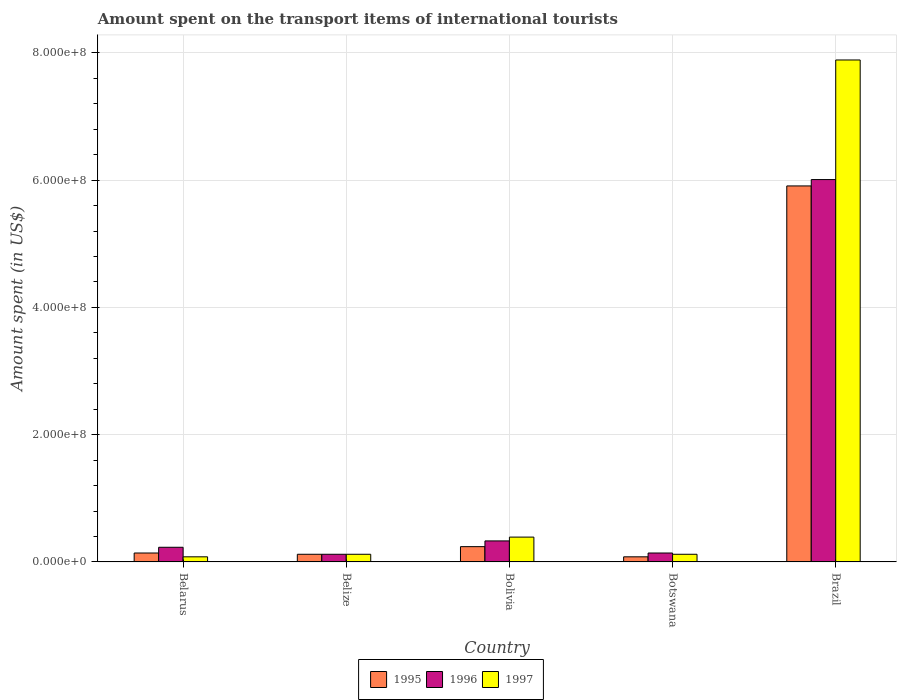How many groups of bars are there?
Your answer should be compact. 5. Are the number of bars per tick equal to the number of legend labels?
Give a very brief answer. Yes. How many bars are there on the 5th tick from the left?
Make the answer very short. 3. How many bars are there on the 1st tick from the right?
Ensure brevity in your answer.  3. What is the label of the 1st group of bars from the left?
Keep it short and to the point. Belarus. In how many cases, is the number of bars for a given country not equal to the number of legend labels?
Make the answer very short. 0. Across all countries, what is the maximum amount spent on the transport items of international tourists in 1995?
Provide a short and direct response. 5.91e+08. Across all countries, what is the minimum amount spent on the transport items of international tourists in 1997?
Provide a succinct answer. 8.00e+06. In which country was the amount spent on the transport items of international tourists in 1995 maximum?
Offer a terse response. Brazil. In which country was the amount spent on the transport items of international tourists in 1997 minimum?
Keep it short and to the point. Belarus. What is the total amount spent on the transport items of international tourists in 1997 in the graph?
Provide a short and direct response. 8.60e+08. What is the difference between the amount spent on the transport items of international tourists in 1997 in Belarus and that in Botswana?
Provide a succinct answer. -4.00e+06. What is the difference between the amount spent on the transport items of international tourists in 1996 in Bolivia and the amount spent on the transport items of international tourists in 1997 in Belarus?
Your answer should be very brief. 2.50e+07. What is the average amount spent on the transport items of international tourists in 1997 per country?
Make the answer very short. 1.72e+08. What is the ratio of the amount spent on the transport items of international tourists in 1997 in Belarus to that in Botswana?
Keep it short and to the point. 0.67. Is the amount spent on the transport items of international tourists in 1996 in Belarus less than that in Brazil?
Your answer should be very brief. Yes. Is the difference between the amount spent on the transport items of international tourists in 1996 in Bolivia and Brazil greater than the difference between the amount spent on the transport items of international tourists in 1995 in Bolivia and Brazil?
Give a very brief answer. No. What is the difference between the highest and the second highest amount spent on the transport items of international tourists in 1995?
Your answer should be compact. 5.67e+08. What is the difference between the highest and the lowest amount spent on the transport items of international tourists in 1995?
Keep it short and to the point. 5.83e+08. What does the 2nd bar from the left in Bolivia represents?
Offer a terse response. 1996. What does the 3rd bar from the right in Bolivia represents?
Offer a terse response. 1995. Is it the case that in every country, the sum of the amount spent on the transport items of international tourists in 1995 and amount spent on the transport items of international tourists in 1996 is greater than the amount spent on the transport items of international tourists in 1997?
Your answer should be compact. Yes. Are all the bars in the graph horizontal?
Your response must be concise. No. Does the graph contain any zero values?
Ensure brevity in your answer.  No. How many legend labels are there?
Make the answer very short. 3. What is the title of the graph?
Your answer should be compact. Amount spent on the transport items of international tourists. Does "1965" appear as one of the legend labels in the graph?
Your answer should be very brief. No. What is the label or title of the X-axis?
Provide a short and direct response. Country. What is the label or title of the Y-axis?
Provide a succinct answer. Amount spent (in US$). What is the Amount spent (in US$) of 1995 in Belarus?
Provide a short and direct response. 1.40e+07. What is the Amount spent (in US$) in 1996 in Belarus?
Give a very brief answer. 2.30e+07. What is the Amount spent (in US$) in 1997 in Belarus?
Give a very brief answer. 8.00e+06. What is the Amount spent (in US$) of 1996 in Belize?
Ensure brevity in your answer.  1.20e+07. What is the Amount spent (in US$) of 1995 in Bolivia?
Your answer should be very brief. 2.40e+07. What is the Amount spent (in US$) in 1996 in Bolivia?
Offer a terse response. 3.30e+07. What is the Amount spent (in US$) in 1997 in Bolivia?
Give a very brief answer. 3.90e+07. What is the Amount spent (in US$) in 1996 in Botswana?
Offer a very short reply. 1.40e+07. What is the Amount spent (in US$) in 1997 in Botswana?
Make the answer very short. 1.20e+07. What is the Amount spent (in US$) in 1995 in Brazil?
Provide a short and direct response. 5.91e+08. What is the Amount spent (in US$) of 1996 in Brazil?
Your answer should be compact. 6.01e+08. What is the Amount spent (in US$) of 1997 in Brazil?
Your answer should be compact. 7.89e+08. Across all countries, what is the maximum Amount spent (in US$) of 1995?
Offer a very short reply. 5.91e+08. Across all countries, what is the maximum Amount spent (in US$) of 1996?
Your answer should be compact. 6.01e+08. Across all countries, what is the maximum Amount spent (in US$) in 1997?
Keep it short and to the point. 7.89e+08. Across all countries, what is the minimum Amount spent (in US$) in 1996?
Offer a very short reply. 1.20e+07. What is the total Amount spent (in US$) of 1995 in the graph?
Provide a short and direct response. 6.49e+08. What is the total Amount spent (in US$) of 1996 in the graph?
Give a very brief answer. 6.83e+08. What is the total Amount spent (in US$) of 1997 in the graph?
Keep it short and to the point. 8.60e+08. What is the difference between the Amount spent (in US$) of 1996 in Belarus and that in Belize?
Give a very brief answer. 1.10e+07. What is the difference between the Amount spent (in US$) in 1995 in Belarus and that in Bolivia?
Provide a succinct answer. -1.00e+07. What is the difference between the Amount spent (in US$) in 1996 in Belarus and that in Bolivia?
Provide a short and direct response. -1.00e+07. What is the difference between the Amount spent (in US$) of 1997 in Belarus and that in Bolivia?
Your response must be concise. -3.10e+07. What is the difference between the Amount spent (in US$) of 1995 in Belarus and that in Botswana?
Offer a very short reply. 6.00e+06. What is the difference between the Amount spent (in US$) in 1996 in Belarus and that in Botswana?
Offer a very short reply. 9.00e+06. What is the difference between the Amount spent (in US$) of 1997 in Belarus and that in Botswana?
Offer a terse response. -4.00e+06. What is the difference between the Amount spent (in US$) in 1995 in Belarus and that in Brazil?
Provide a short and direct response. -5.77e+08. What is the difference between the Amount spent (in US$) in 1996 in Belarus and that in Brazil?
Keep it short and to the point. -5.78e+08. What is the difference between the Amount spent (in US$) in 1997 in Belarus and that in Brazil?
Your answer should be compact. -7.81e+08. What is the difference between the Amount spent (in US$) in 1995 in Belize and that in Bolivia?
Offer a very short reply. -1.20e+07. What is the difference between the Amount spent (in US$) of 1996 in Belize and that in Bolivia?
Give a very brief answer. -2.10e+07. What is the difference between the Amount spent (in US$) in 1997 in Belize and that in Bolivia?
Provide a succinct answer. -2.70e+07. What is the difference between the Amount spent (in US$) of 1995 in Belize and that in Botswana?
Keep it short and to the point. 4.00e+06. What is the difference between the Amount spent (in US$) of 1996 in Belize and that in Botswana?
Provide a short and direct response. -2.00e+06. What is the difference between the Amount spent (in US$) in 1995 in Belize and that in Brazil?
Your response must be concise. -5.79e+08. What is the difference between the Amount spent (in US$) in 1996 in Belize and that in Brazil?
Offer a very short reply. -5.89e+08. What is the difference between the Amount spent (in US$) in 1997 in Belize and that in Brazil?
Offer a very short reply. -7.77e+08. What is the difference between the Amount spent (in US$) in 1995 in Bolivia and that in Botswana?
Offer a terse response. 1.60e+07. What is the difference between the Amount spent (in US$) of 1996 in Bolivia and that in Botswana?
Keep it short and to the point. 1.90e+07. What is the difference between the Amount spent (in US$) of 1997 in Bolivia and that in Botswana?
Give a very brief answer. 2.70e+07. What is the difference between the Amount spent (in US$) of 1995 in Bolivia and that in Brazil?
Ensure brevity in your answer.  -5.67e+08. What is the difference between the Amount spent (in US$) in 1996 in Bolivia and that in Brazil?
Your answer should be compact. -5.68e+08. What is the difference between the Amount spent (in US$) of 1997 in Bolivia and that in Brazil?
Provide a succinct answer. -7.50e+08. What is the difference between the Amount spent (in US$) in 1995 in Botswana and that in Brazil?
Offer a very short reply. -5.83e+08. What is the difference between the Amount spent (in US$) of 1996 in Botswana and that in Brazil?
Your answer should be compact. -5.87e+08. What is the difference between the Amount spent (in US$) in 1997 in Botswana and that in Brazil?
Give a very brief answer. -7.77e+08. What is the difference between the Amount spent (in US$) in 1995 in Belarus and the Amount spent (in US$) in 1997 in Belize?
Offer a terse response. 2.00e+06. What is the difference between the Amount spent (in US$) in 1996 in Belarus and the Amount spent (in US$) in 1997 in Belize?
Provide a short and direct response. 1.10e+07. What is the difference between the Amount spent (in US$) in 1995 in Belarus and the Amount spent (in US$) in 1996 in Bolivia?
Your answer should be very brief. -1.90e+07. What is the difference between the Amount spent (in US$) in 1995 in Belarus and the Amount spent (in US$) in 1997 in Bolivia?
Your response must be concise. -2.50e+07. What is the difference between the Amount spent (in US$) of 1996 in Belarus and the Amount spent (in US$) of 1997 in Bolivia?
Keep it short and to the point. -1.60e+07. What is the difference between the Amount spent (in US$) in 1995 in Belarus and the Amount spent (in US$) in 1997 in Botswana?
Keep it short and to the point. 2.00e+06. What is the difference between the Amount spent (in US$) in 1996 in Belarus and the Amount spent (in US$) in 1997 in Botswana?
Your response must be concise. 1.10e+07. What is the difference between the Amount spent (in US$) of 1995 in Belarus and the Amount spent (in US$) of 1996 in Brazil?
Your response must be concise. -5.87e+08. What is the difference between the Amount spent (in US$) in 1995 in Belarus and the Amount spent (in US$) in 1997 in Brazil?
Ensure brevity in your answer.  -7.75e+08. What is the difference between the Amount spent (in US$) in 1996 in Belarus and the Amount spent (in US$) in 1997 in Brazil?
Provide a short and direct response. -7.66e+08. What is the difference between the Amount spent (in US$) in 1995 in Belize and the Amount spent (in US$) in 1996 in Bolivia?
Keep it short and to the point. -2.10e+07. What is the difference between the Amount spent (in US$) of 1995 in Belize and the Amount spent (in US$) of 1997 in Bolivia?
Your answer should be compact. -2.70e+07. What is the difference between the Amount spent (in US$) in 1996 in Belize and the Amount spent (in US$) in 1997 in Bolivia?
Your response must be concise. -2.70e+07. What is the difference between the Amount spent (in US$) of 1995 in Belize and the Amount spent (in US$) of 1996 in Brazil?
Offer a very short reply. -5.89e+08. What is the difference between the Amount spent (in US$) in 1995 in Belize and the Amount spent (in US$) in 1997 in Brazil?
Your response must be concise. -7.77e+08. What is the difference between the Amount spent (in US$) in 1996 in Belize and the Amount spent (in US$) in 1997 in Brazil?
Make the answer very short. -7.77e+08. What is the difference between the Amount spent (in US$) of 1995 in Bolivia and the Amount spent (in US$) of 1996 in Botswana?
Ensure brevity in your answer.  1.00e+07. What is the difference between the Amount spent (in US$) of 1996 in Bolivia and the Amount spent (in US$) of 1997 in Botswana?
Ensure brevity in your answer.  2.10e+07. What is the difference between the Amount spent (in US$) of 1995 in Bolivia and the Amount spent (in US$) of 1996 in Brazil?
Make the answer very short. -5.77e+08. What is the difference between the Amount spent (in US$) in 1995 in Bolivia and the Amount spent (in US$) in 1997 in Brazil?
Your response must be concise. -7.65e+08. What is the difference between the Amount spent (in US$) in 1996 in Bolivia and the Amount spent (in US$) in 1997 in Brazil?
Make the answer very short. -7.56e+08. What is the difference between the Amount spent (in US$) in 1995 in Botswana and the Amount spent (in US$) in 1996 in Brazil?
Ensure brevity in your answer.  -5.93e+08. What is the difference between the Amount spent (in US$) of 1995 in Botswana and the Amount spent (in US$) of 1997 in Brazil?
Offer a terse response. -7.81e+08. What is the difference between the Amount spent (in US$) of 1996 in Botswana and the Amount spent (in US$) of 1997 in Brazil?
Your response must be concise. -7.75e+08. What is the average Amount spent (in US$) of 1995 per country?
Offer a very short reply. 1.30e+08. What is the average Amount spent (in US$) of 1996 per country?
Your answer should be very brief. 1.37e+08. What is the average Amount spent (in US$) of 1997 per country?
Ensure brevity in your answer.  1.72e+08. What is the difference between the Amount spent (in US$) in 1995 and Amount spent (in US$) in 1996 in Belarus?
Offer a terse response. -9.00e+06. What is the difference between the Amount spent (in US$) in 1996 and Amount spent (in US$) in 1997 in Belarus?
Your response must be concise. 1.50e+07. What is the difference between the Amount spent (in US$) of 1996 and Amount spent (in US$) of 1997 in Belize?
Offer a very short reply. 0. What is the difference between the Amount spent (in US$) in 1995 and Amount spent (in US$) in 1996 in Bolivia?
Offer a very short reply. -9.00e+06. What is the difference between the Amount spent (in US$) in 1995 and Amount spent (in US$) in 1997 in Bolivia?
Ensure brevity in your answer.  -1.50e+07. What is the difference between the Amount spent (in US$) in 1996 and Amount spent (in US$) in 1997 in Bolivia?
Provide a short and direct response. -6.00e+06. What is the difference between the Amount spent (in US$) in 1995 and Amount spent (in US$) in 1996 in Botswana?
Keep it short and to the point. -6.00e+06. What is the difference between the Amount spent (in US$) of 1995 and Amount spent (in US$) of 1996 in Brazil?
Offer a terse response. -1.00e+07. What is the difference between the Amount spent (in US$) of 1995 and Amount spent (in US$) of 1997 in Brazil?
Your answer should be very brief. -1.98e+08. What is the difference between the Amount spent (in US$) of 1996 and Amount spent (in US$) of 1997 in Brazil?
Your answer should be very brief. -1.88e+08. What is the ratio of the Amount spent (in US$) of 1995 in Belarus to that in Belize?
Offer a very short reply. 1.17. What is the ratio of the Amount spent (in US$) in 1996 in Belarus to that in Belize?
Your answer should be compact. 1.92. What is the ratio of the Amount spent (in US$) in 1995 in Belarus to that in Bolivia?
Give a very brief answer. 0.58. What is the ratio of the Amount spent (in US$) of 1996 in Belarus to that in Bolivia?
Keep it short and to the point. 0.7. What is the ratio of the Amount spent (in US$) in 1997 in Belarus to that in Bolivia?
Your answer should be compact. 0.21. What is the ratio of the Amount spent (in US$) of 1996 in Belarus to that in Botswana?
Give a very brief answer. 1.64. What is the ratio of the Amount spent (in US$) of 1995 in Belarus to that in Brazil?
Your answer should be very brief. 0.02. What is the ratio of the Amount spent (in US$) in 1996 in Belarus to that in Brazil?
Provide a succinct answer. 0.04. What is the ratio of the Amount spent (in US$) of 1997 in Belarus to that in Brazil?
Keep it short and to the point. 0.01. What is the ratio of the Amount spent (in US$) in 1995 in Belize to that in Bolivia?
Your answer should be very brief. 0.5. What is the ratio of the Amount spent (in US$) in 1996 in Belize to that in Bolivia?
Your answer should be very brief. 0.36. What is the ratio of the Amount spent (in US$) of 1997 in Belize to that in Bolivia?
Your answer should be very brief. 0.31. What is the ratio of the Amount spent (in US$) of 1995 in Belize to that in Botswana?
Provide a succinct answer. 1.5. What is the ratio of the Amount spent (in US$) of 1996 in Belize to that in Botswana?
Give a very brief answer. 0.86. What is the ratio of the Amount spent (in US$) of 1995 in Belize to that in Brazil?
Give a very brief answer. 0.02. What is the ratio of the Amount spent (in US$) in 1997 in Belize to that in Brazil?
Offer a very short reply. 0.02. What is the ratio of the Amount spent (in US$) of 1996 in Bolivia to that in Botswana?
Offer a very short reply. 2.36. What is the ratio of the Amount spent (in US$) of 1997 in Bolivia to that in Botswana?
Keep it short and to the point. 3.25. What is the ratio of the Amount spent (in US$) in 1995 in Bolivia to that in Brazil?
Keep it short and to the point. 0.04. What is the ratio of the Amount spent (in US$) of 1996 in Bolivia to that in Brazil?
Keep it short and to the point. 0.05. What is the ratio of the Amount spent (in US$) in 1997 in Bolivia to that in Brazil?
Your answer should be compact. 0.05. What is the ratio of the Amount spent (in US$) in 1995 in Botswana to that in Brazil?
Offer a very short reply. 0.01. What is the ratio of the Amount spent (in US$) in 1996 in Botswana to that in Brazil?
Ensure brevity in your answer.  0.02. What is the ratio of the Amount spent (in US$) in 1997 in Botswana to that in Brazil?
Your answer should be very brief. 0.02. What is the difference between the highest and the second highest Amount spent (in US$) in 1995?
Your response must be concise. 5.67e+08. What is the difference between the highest and the second highest Amount spent (in US$) in 1996?
Your answer should be very brief. 5.68e+08. What is the difference between the highest and the second highest Amount spent (in US$) of 1997?
Ensure brevity in your answer.  7.50e+08. What is the difference between the highest and the lowest Amount spent (in US$) in 1995?
Offer a very short reply. 5.83e+08. What is the difference between the highest and the lowest Amount spent (in US$) of 1996?
Offer a very short reply. 5.89e+08. What is the difference between the highest and the lowest Amount spent (in US$) of 1997?
Offer a very short reply. 7.81e+08. 